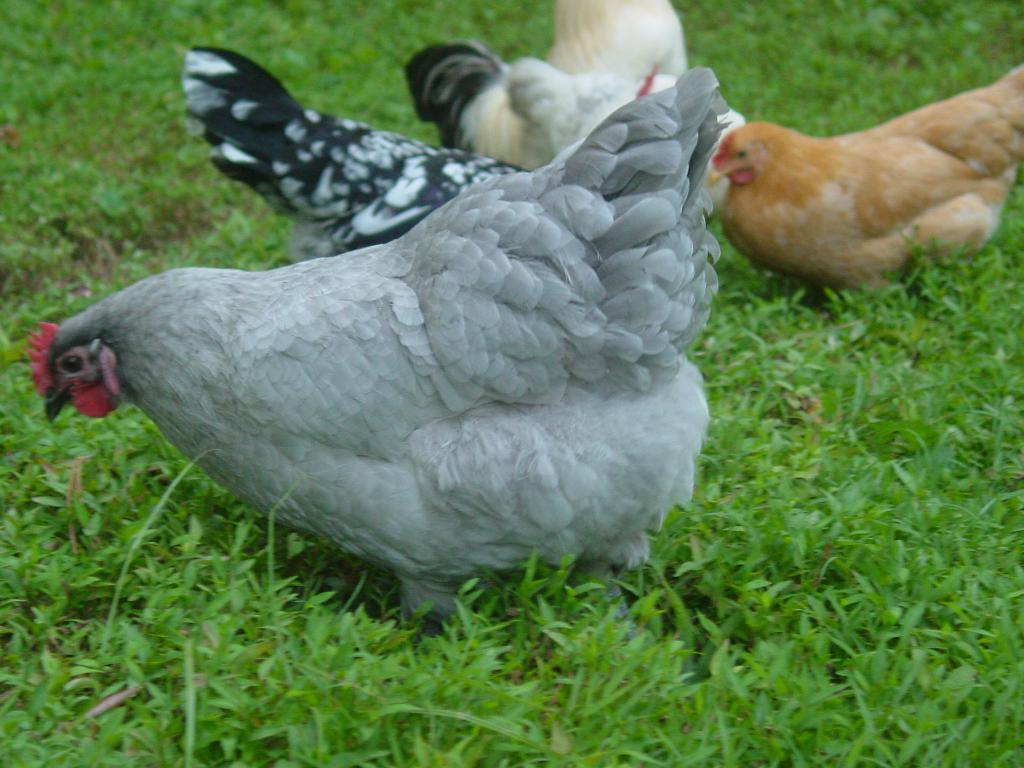What type of animals are present in the image? There are hens in the image. What type of vegetation can be seen at the bottom of the image? There is grass at the bottom of the image. What type of hat is the hen wearing in the image? There are no hats present in the image, as hens do not wear hats. Can you see any popcorn in the image? There is no popcorn present in the image. 